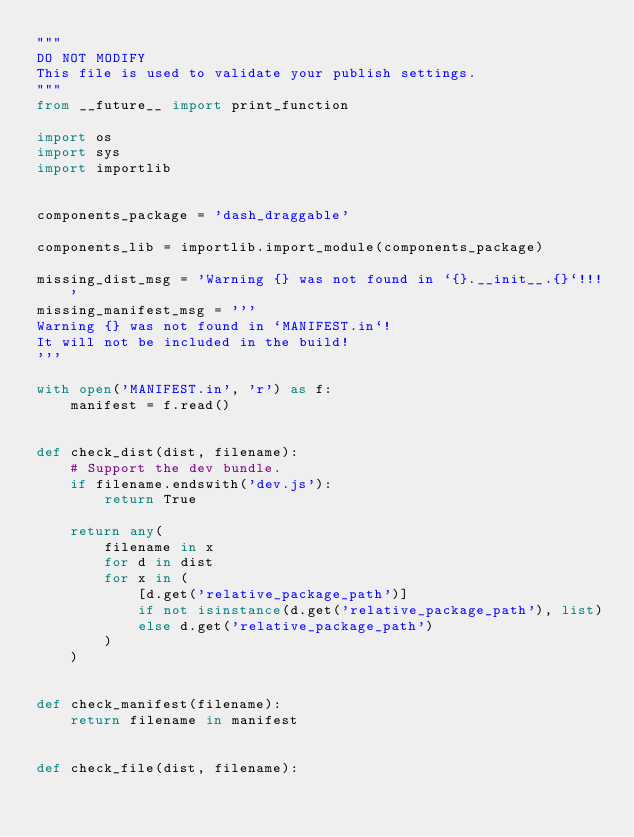Convert code to text. <code><loc_0><loc_0><loc_500><loc_500><_Python_>"""
DO NOT MODIFY
This file is used to validate your publish settings.
"""
from __future__ import print_function

import os
import sys
import importlib


components_package = 'dash_draggable'

components_lib = importlib.import_module(components_package)

missing_dist_msg = 'Warning {} was not found in `{}.__init__.{}`!!!'
missing_manifest_msg = '''
Warning {} was not found in `MANIFEST.in`!
It will not be included in the build!
'''

with open('MANIFEST.in', 'r') as f:
    manifest = f.read()


def check_dist(dist, filename):
    # Support the dev bundle.
    if filename.endswith('dev.js'):
        return True

    return any(
        filename in x
        for d in dist
        for x in (
            [d.get('relative_package_path')]
            if not isinstance(d.get('relative_package_path'), list)
            else d.get('relative_package_path')
        )
    )


def check_manifest(filename):
    return filename in manifest


def check_file(dist, filename):</code> 